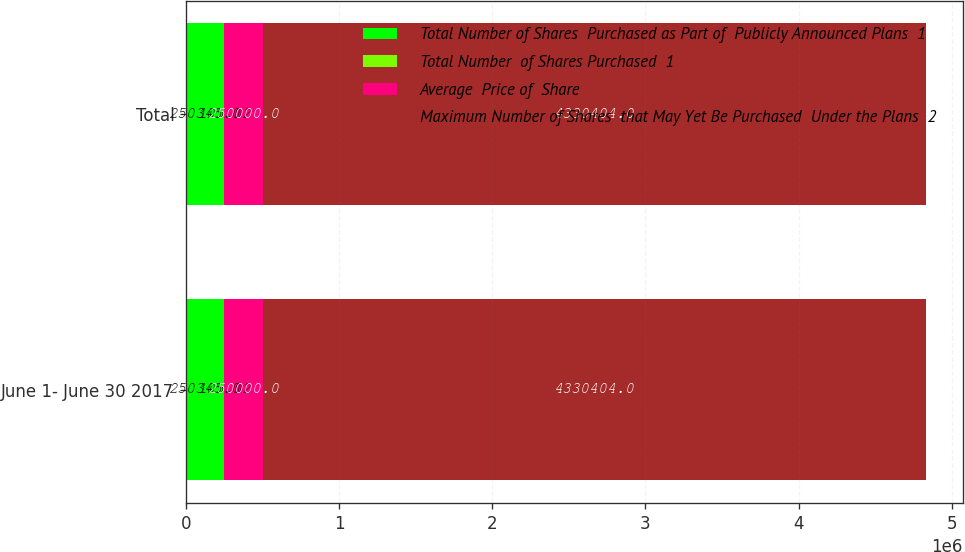Convert chart. <chart><loc_0><loc_0><loc_500><loc_500><stacked_bar_chart><ecel><fcel>June 1- June 30 2017<fcel>Total<nl><fcel>Total Number of Shares  Purchased as Part of  Publicly Announced Plans  1<fcel>250345<fcel>250345<nl><fcel>Total Number  of Shares Purchased  1<fcel>105.02<fcel>105.02<nl><fcel>Average  Price of  Share<fcel>250000<fcel>250000<nl><fcel>Maximum Number of Shares  that May Yet Be Purchased  Under the Plans  2<fcel>4.3304e+06<fcel>4.3304e+06<nl></chart> 